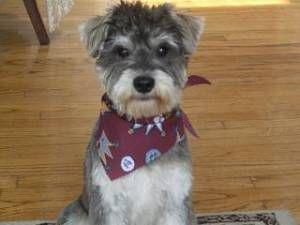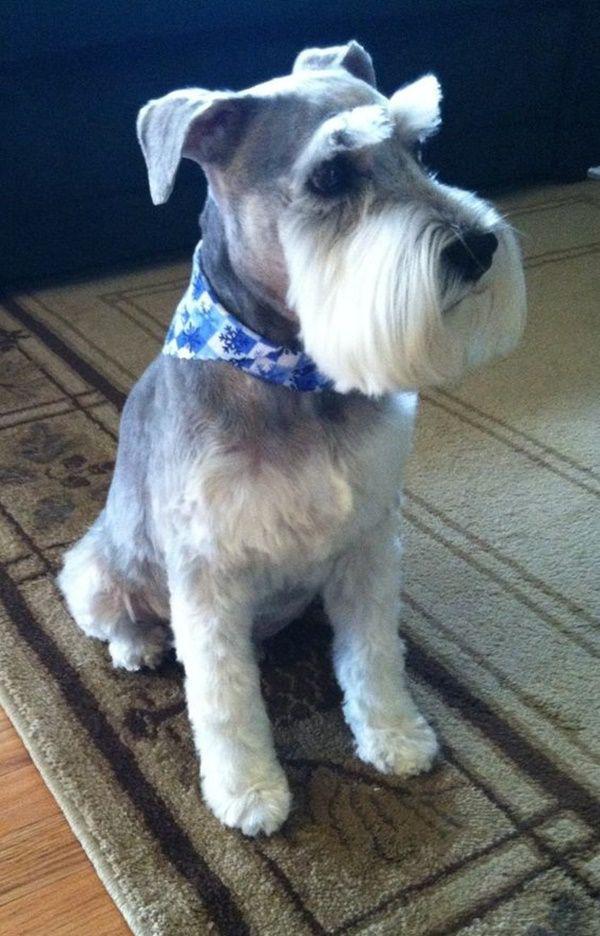The first image is the image on the left, the second image is the image on the right. Considering the images on both sides, is "The dog in the image on the right is standing on all fours." valid? Answer yes or no. No. The first image is the image on the left, the second image is the image on the right. Considering the images on both sides, is "One camera-gazing schnauzer is standing on all fours on a surface that looks like cement." valid? Answer yes or no. No. 